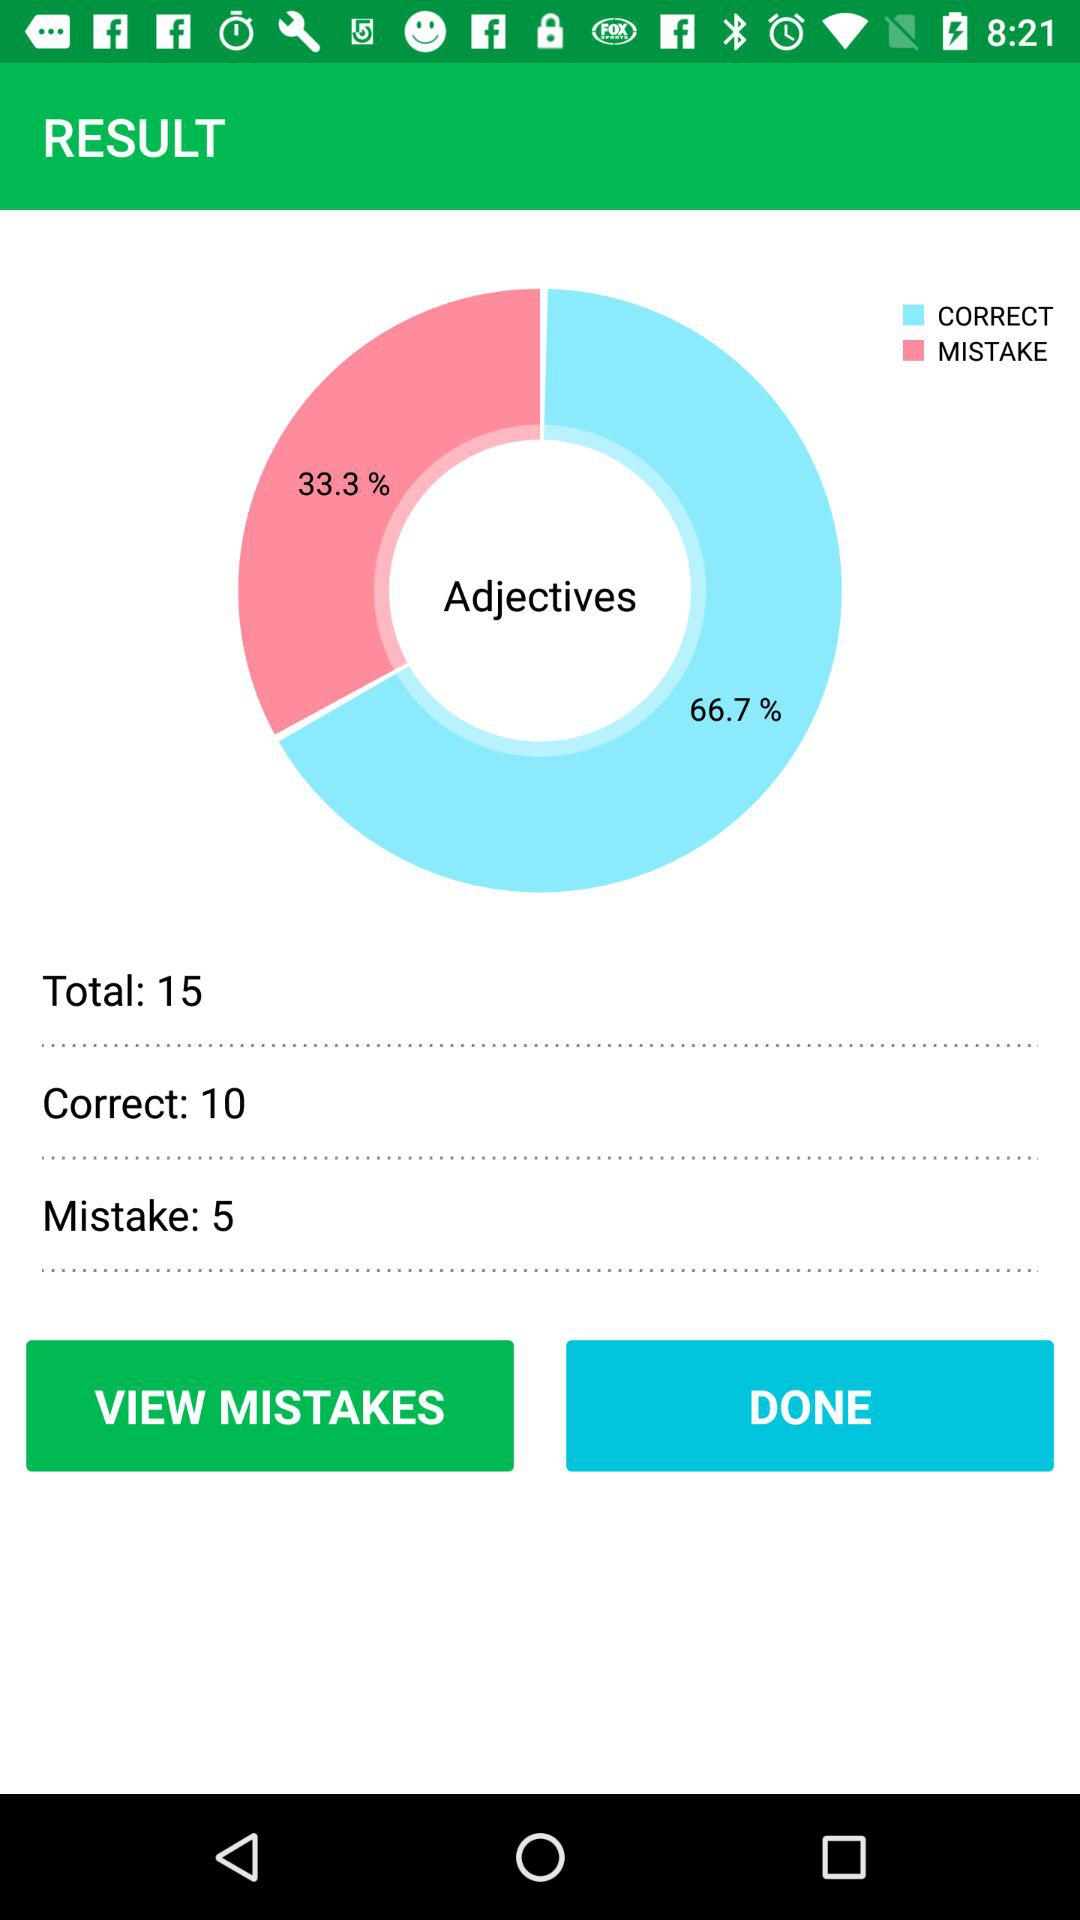What is the percentage of correct adjectives? The percentage of correct adjectives is 66.7. 